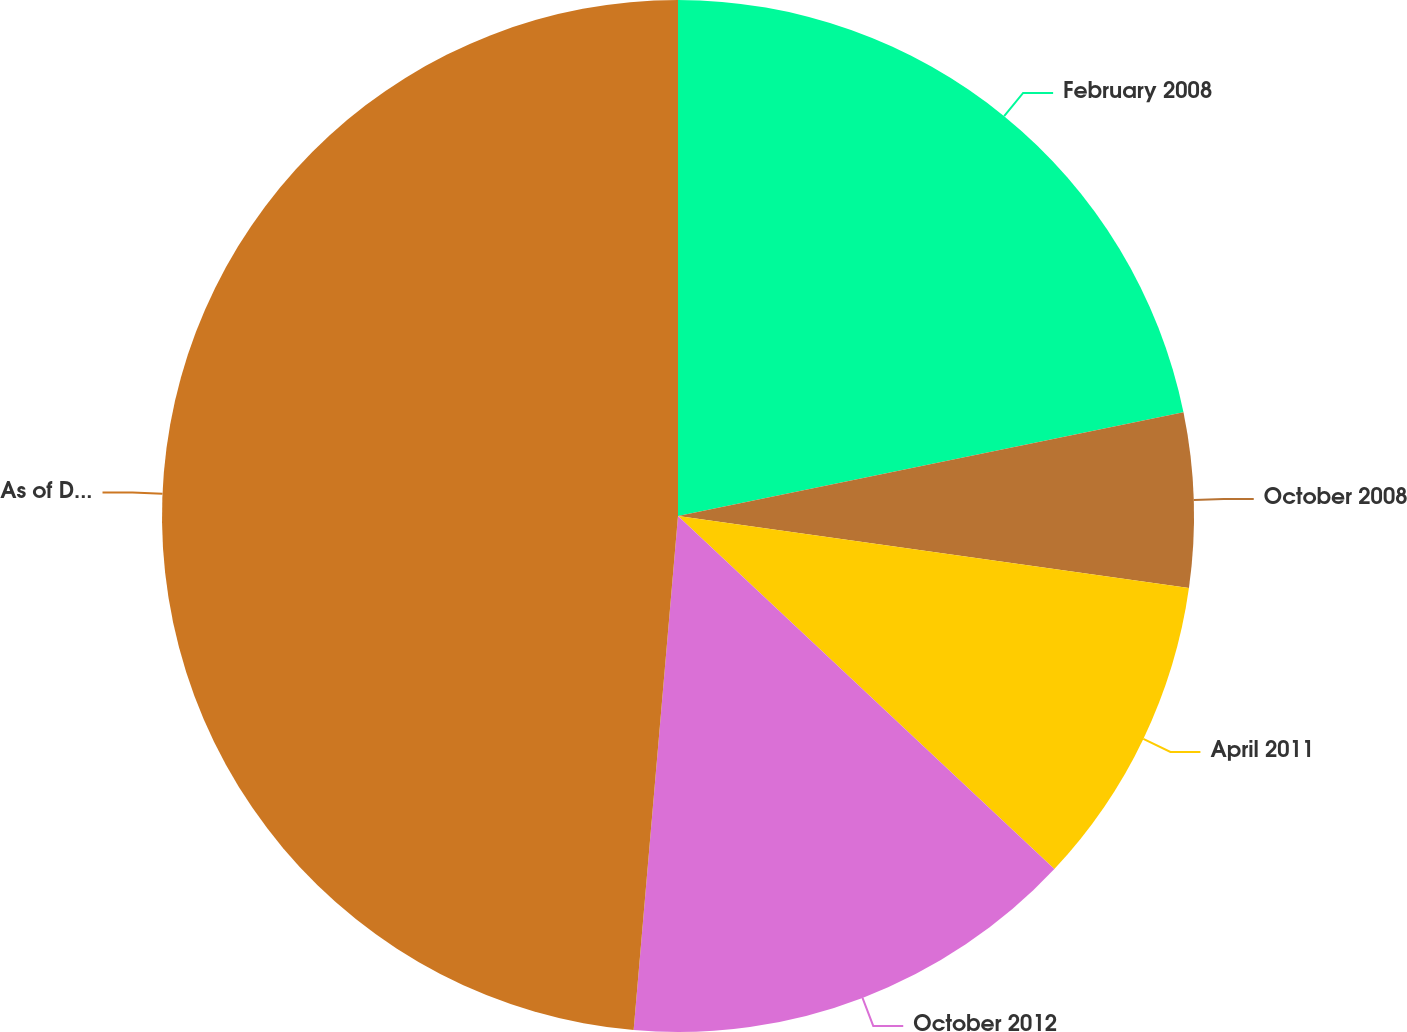Convert chart. <chart><loc_0><loc_0><loc_500><loc_500><pie_chart><fcel>February 2008<fcel>October 2008<fcel>April 2011<fcel>October 2012<fcel>As of December 31 2012<nl><fcel>21.78%<fcel>5.45%<fcel>9.76%<fcel>14.38%<fcel>48.63%<nl></chart> 